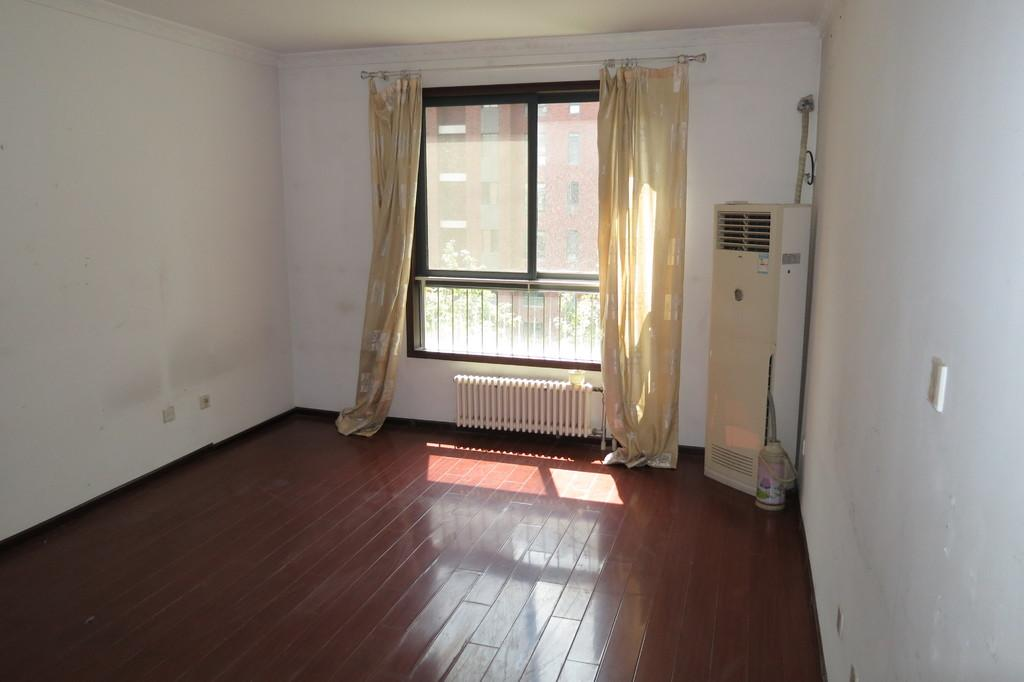What can be seen through the window in the image? There is no information about what can be seen through the window in the image. What type of structure is visible in the image? There is a building in the image. What type of vegetation is present in the image? There are trees in the image. What type of window treatment is visible in the image? There is a curtain in the image. What type of walls are present in the image? There are walls in the image. What type of cooling system is visible in the image? There is an air conditioner in the image. What type of electrical component is present in the image? There is a wire in the image. What type of object is present on the wooden floor in the image? There is an object on a wooden floor in the image, but the specific type of object is not mentioned. What type of smell can be detected in the image? There is no information about any smell in the image. What type of box is present in the image? There is no box present in the image. What type of animal can be seen in the image? There is no animal present in the image. 